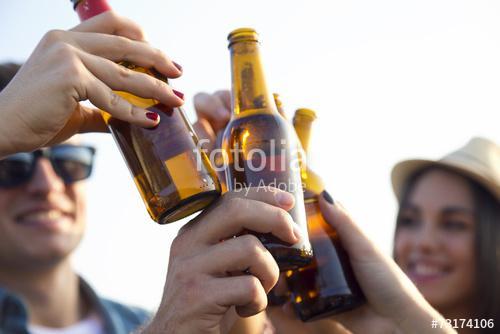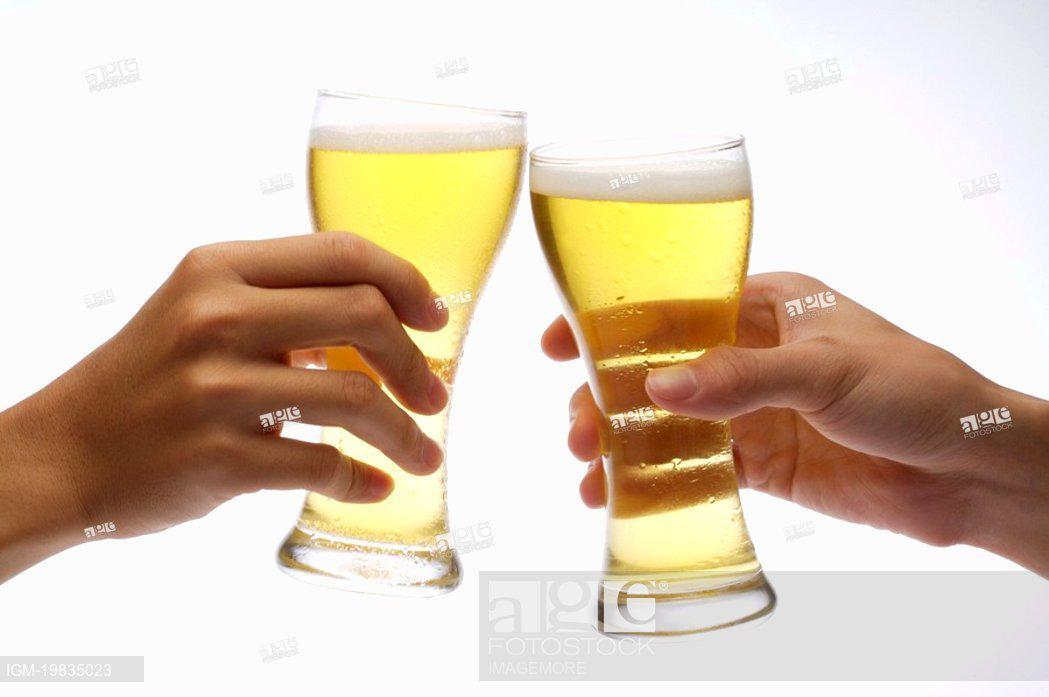The first image is the image on the left, the second image is the image on the right. For the images displayed, is the sentence "A woman is smiling and looking to the left in the left image of the pair." factually correct? Answer yes or no. Yes. 